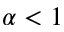<formula> <loc_0><loc_0><loc_500><loc_500>\alpha < 1</formula> 